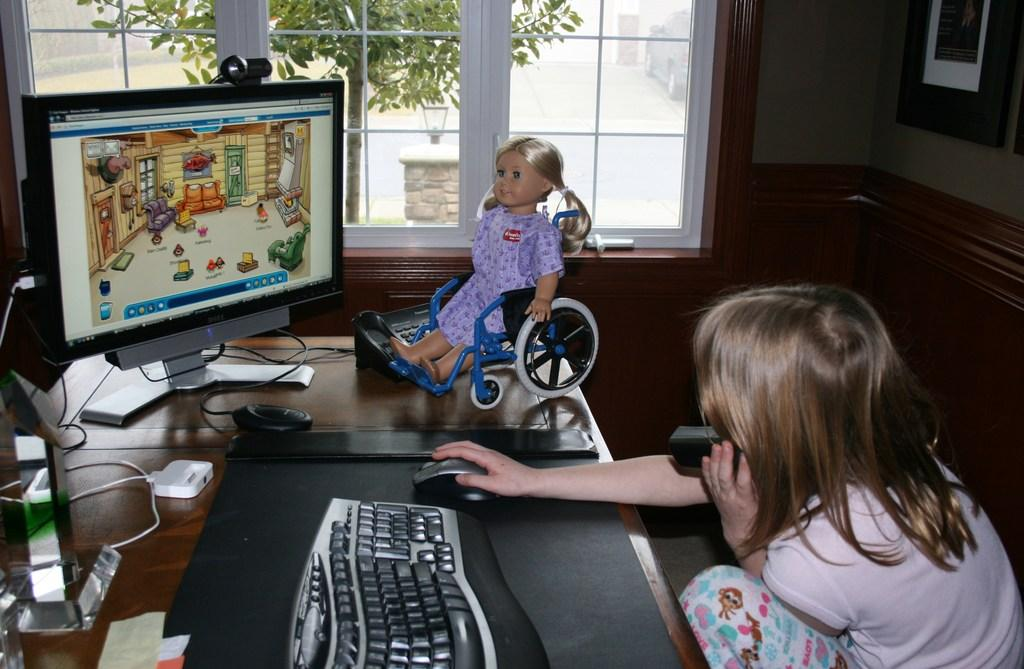What is the girl doing in the image? The girl is seated and holding a mobile phone in her hand. What else can be seen in the girl's hands? The girl's other hand is on a mouse. What electronic device is present in the image? There is a computer in the image. What type of vegetation is visible in the image? There is a tree visible in the image. What object in the image is typically used for play? There is a toy in the image. What type of note is hanging from the tree in the image? There is no note hanging from the tree in the image; only the tree is visible. 